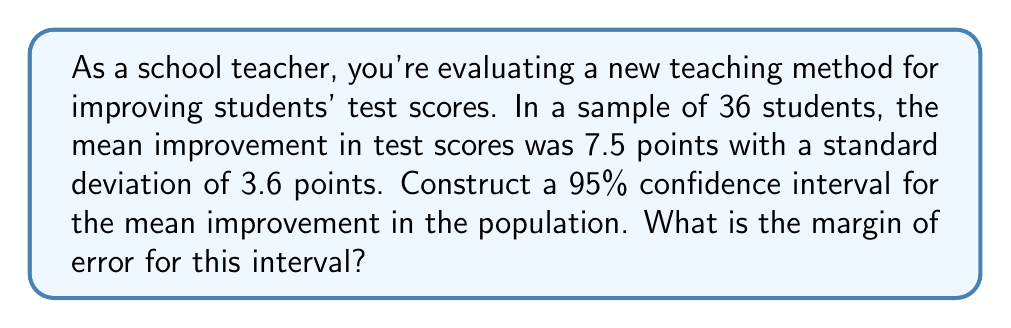Teach me how to tackle this problem. To construct a confidence interval and find the margin of error, we'll follow these steps:

1) The formula for the margin of error (ME) is:

   $$ ME = t_{\alpha/2} \cdot \frac{s}{\sqrt{n}} $$

   where $t_{\alpha/2}$ is the t-value for a 95% confidence interval, $s$ is the sample standard deviation, and $n$ is the sample size.

2) We know:
   - Sample size, $n = 36$
   - Sample mean, $\bar{x} = 7.5$
   - Sample standard deviation, $s = 3.6$
   - Confidence level = 95%, so $\alpha = 0.05$

3) For a 95% confidence interval with 35 degrees of freedom (n - 1 = 35), the t-value is approximately 2.030 (from t-distribution table).

4) Now, let's calculate the margin of error:

   $$ ME = 2.030 \cdot \frac{3.6}{\sqrt{36}} = 2.030 \cdot \frac{3.6}{6} = 2.030 \cdot 0.6 = 1.218 $$

5) The margin of error is approximately 1.218 points.

6) The confidence interval is constructed as:

   $$ \text{CI} = \bar{x} \pm ME = 7.5 \pm 1.218 = (6.282, 8.718) $$

Therefore, we can be 95% confident that the true population mean improvement lies between 6.282 and 8.718 points.
Answer: 1.218 points 